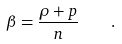<formula> <loc_0><loc_0><loc_500><loc_500>\beta = \frac { \rho + p } { n } \quad .</formula> 